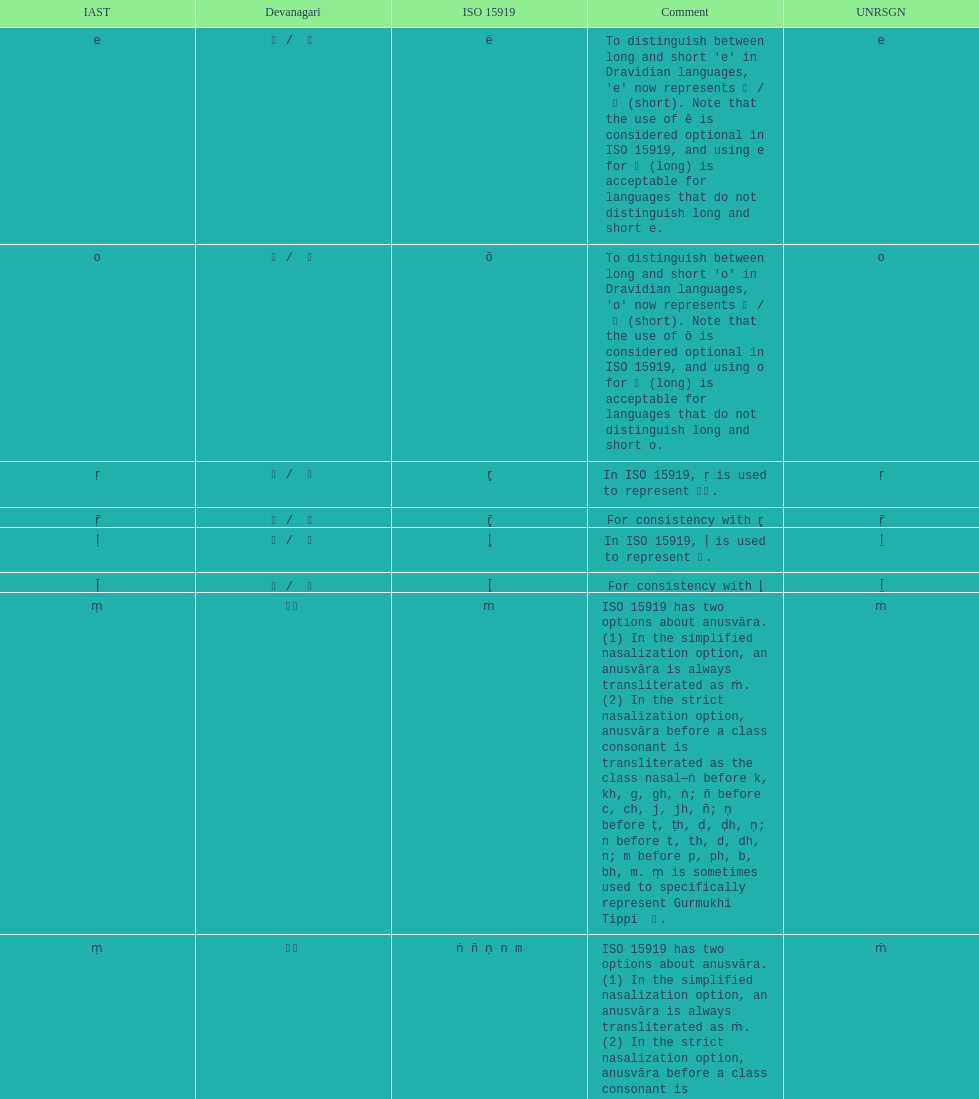Which devanagaria means the same as this iast letter: o? ओ / ो. 